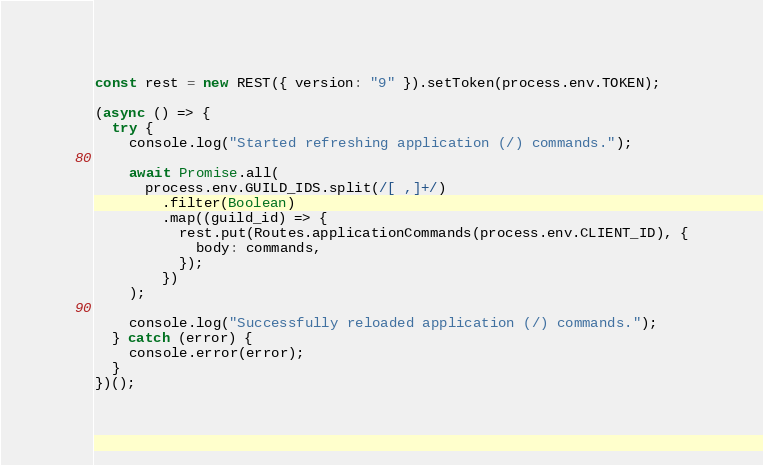Convert code to text. <code><loc_0><loc_0><loc_500><loc_500><_JavaScript_>
const rest = new REST({ version: "9" }).setToken(process.env.TOKEN);

(async () => {
  try {
    console.log("Started refreshing application (/) commands.");

    await Promise.all(
      process.env.GUILD_IDS.split(/[ ,]+/)
        .filter(Boolean)
        .map((guild_id) => {
          rest.put(Routes.applicationCommands(process.env.CLIENT_ID), {
            body: commands,
          });
        })
    );

    console.log("Successfully reloaded application (/) commands.");
  } catch (error) {
    console.error(error);
  }
})();
</code> 